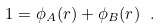Convert formula to latex. <formula><loc_0><loc_0><loc_500><loc_500>1 = \phi _ { A } ( r ) + \phi _ { B } ( r ) \ .</formula> 